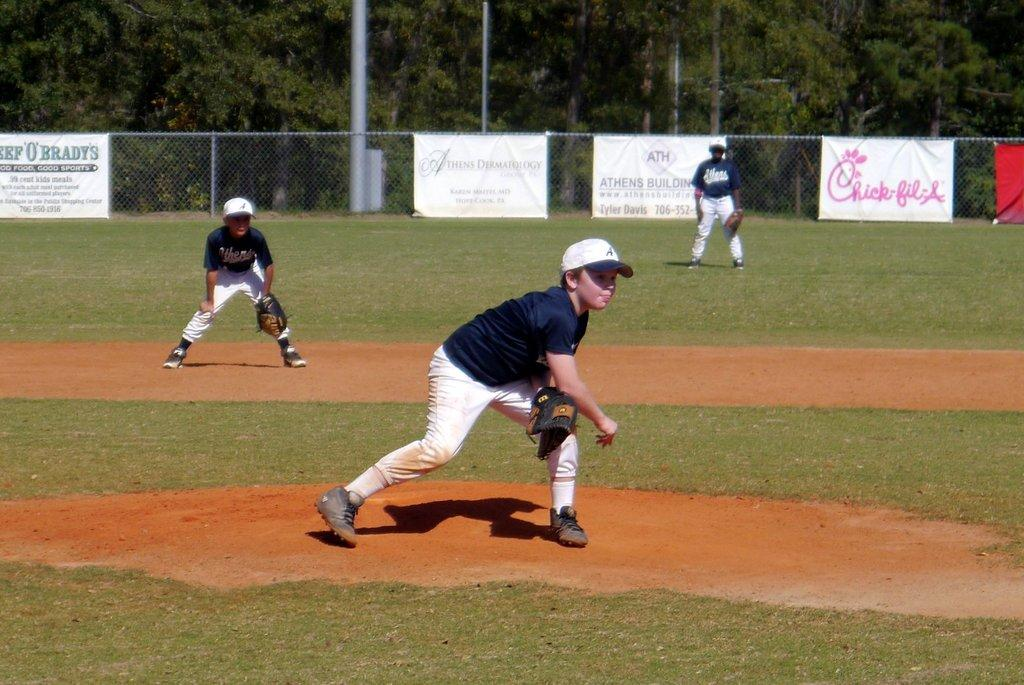<image>
Relay a brief, clear account of the picture shown. Boys play baseball at a field with a Chick-fil-A banner on the fence. 